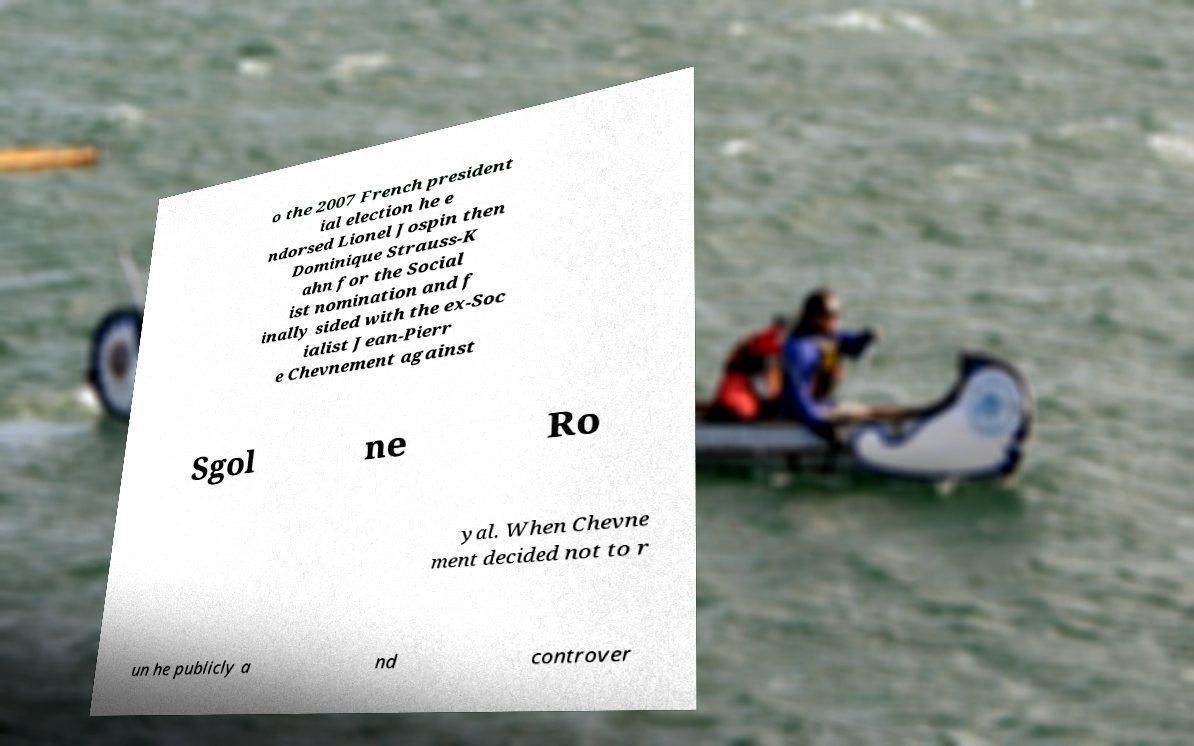I need the written content from this picture converted into text. Can you do that? o the 2007 French president ial election he e ndorsed Lionel Jospin then Dominique Strauss-K ahn for the Social ist nomination and f inally sided with the ex-Soc ialist Jean-Pierr e Chevnement against Sgol ne Ro yal. When Chevne ment decided not to r un he publicly a nd controver 